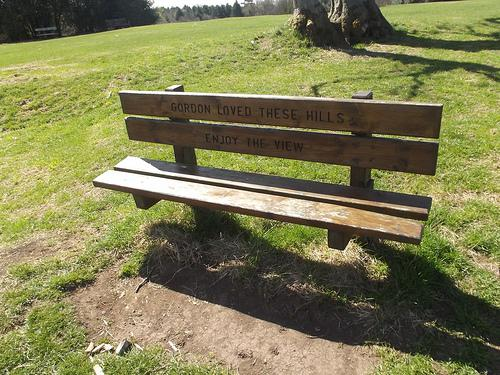Question: what is written on the bench?
Choices:
A. Sit.
B. Throw away trash.
C. Sidwalk.
D. Gordon loved these hills. Enjoy the view.
Answer with the letter. Answer: D Question: what color is the bench?
Choices:
A. Green.
B. Red.
C. Tan.
D. Brown.
Answer with the letter. Answer: D 